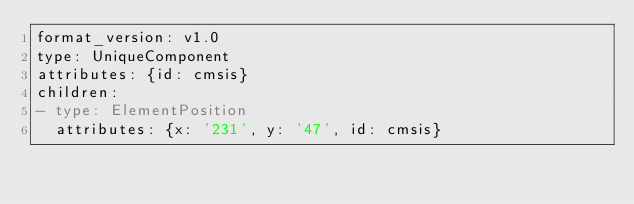<code> <loc_0><loc_0><loc_500><loc_500><_YAML_>format_version: v1.0
type: UniqueComponent
attributes: {id: cmsis}
children:
- type: ElementPosition
  attributes: {x: '231', y: '47', id: cmsis}
</code> 